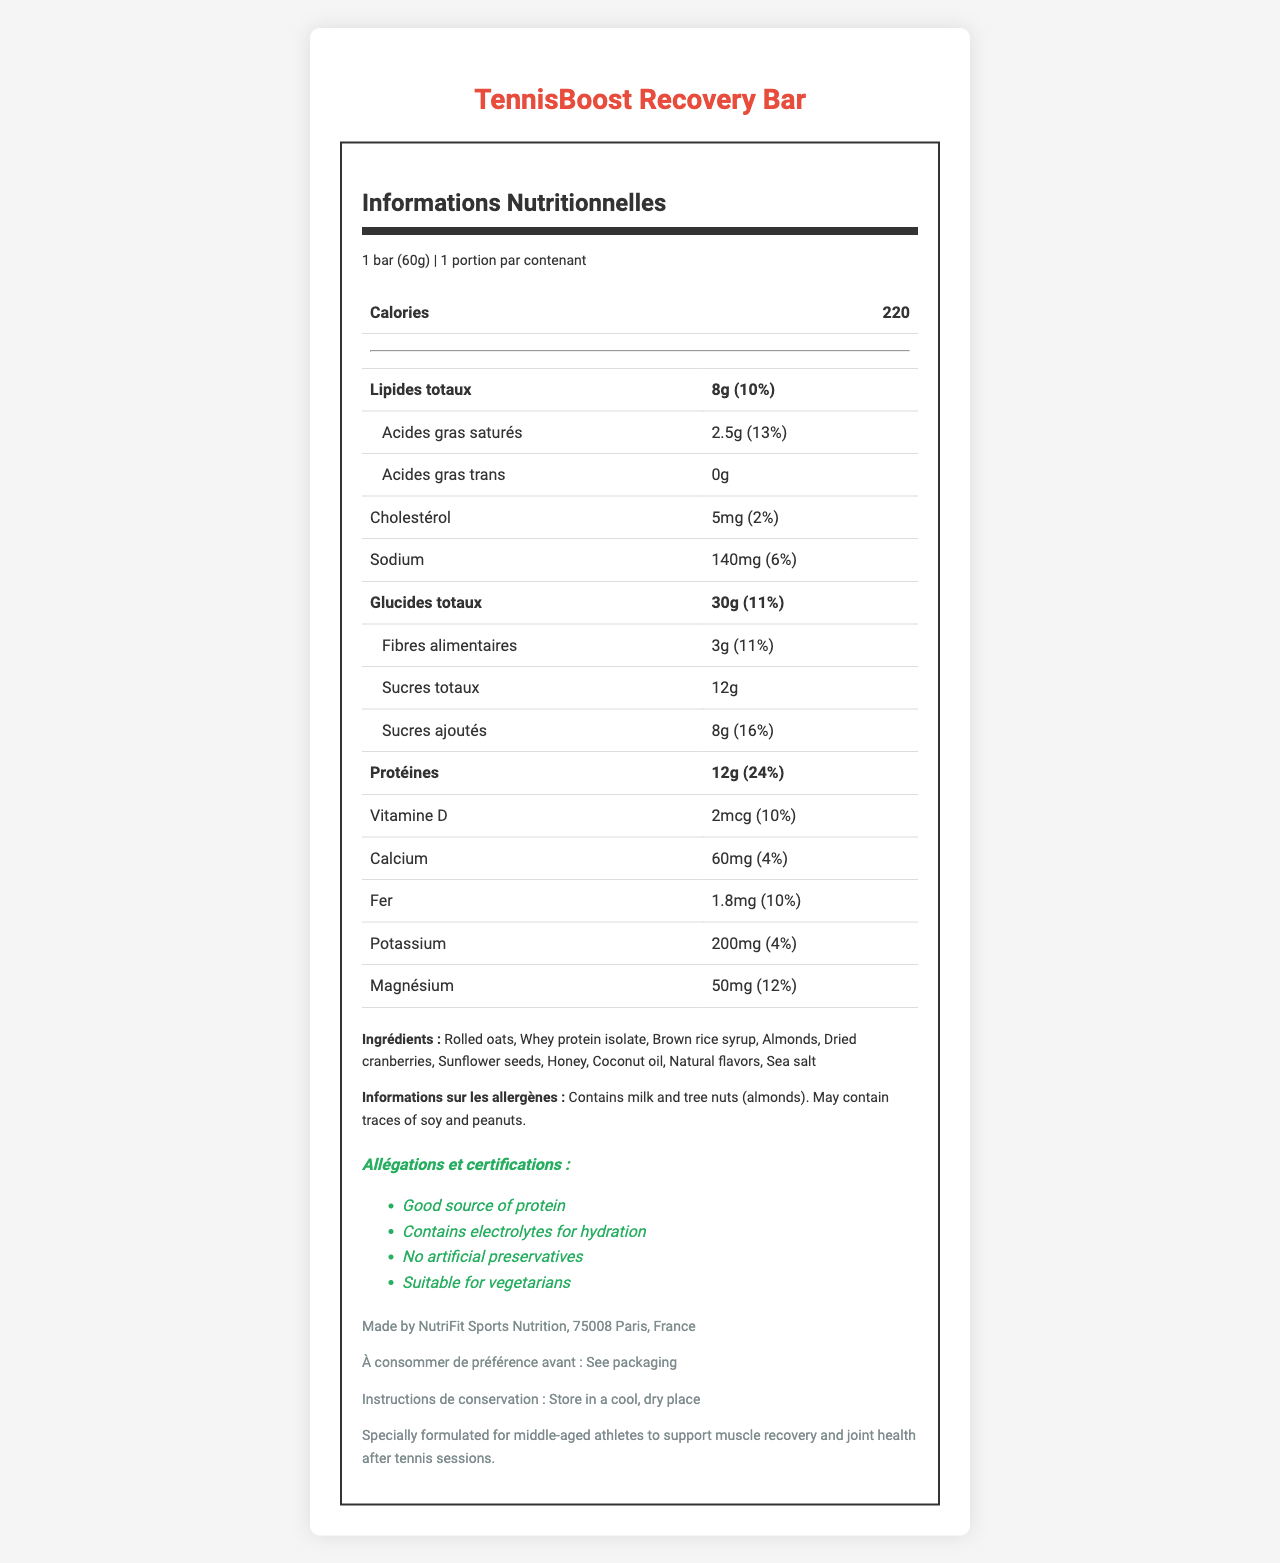what is the serving size of the TennisBoost Recovery Bar? The document specifies the serving size as "1 bar (60g)" clearly under the nutrition information.
Answer: 1 bar (60g) How many calories are there per serving of the TennisBoost Recovery Bar? The document mentions that there are 220 calories per serving, indicated in the nutrition facts.
Answer: 220 calories What is the amount of protein in one serving? The nutrition label states that one serving contains 12g of protein.
Answer: 12g What allergens are present in the TennisBoost Recovery Bar? The allergen information section indicates that the bar contains milk and tree nuts (almonds).
Answer: Milk and tree nuts (almonds) What percentage of the daily value of Vitamin D does one bar provide? According to the nutrition facts, one bar provides 10% of the daily value of Vitamin D.
Answer: 10% How much dietary fiber does the bar contain per serving? The document states that there are 3g of dietary fiber per serving.
Answer: 3g Which of the following ingredients is not listed for the TennisBoost Recovery Bar? A. Whey protein isolate B. Honey C. Dark chocolate D. Sunflower seeds The listed ingredients in the document are rolled oats, whey protein isolate, brown rice syrup, almonds, dried cranberries, sunflower seeds, honey, coconut oil, natural flavors, and sea salt, which does not include dark chocolate.
Answer: C. Dark chocolate Which of the following is a claim or certification made about the TennisBoost Recovery Bar? A. Gluten-free B. Good source of protein C. Contains artificial preservatives Among the claims and certifications, "Good source of protein" is mentioned, whereas the bar actually claims "No artificial preservatives".
Answer: B. Good source of protein Is this recovery bar suitable for vegetarians? The claims and certifications section states that the product is suitable for vegetarians.
Answer: Yes How should the TennisBoost Recovery Bar be stored? The storage instructions in the document specify storing the bar in a cool, dry place.
Answer: In a cool, dry place Does the Nutrition Facts Label mention anything about gluten? The Nutrition Facts Label does not provide any information concerning gluten.
Answer: No Summarize the document's main idea. The document provides a comprehensive overview of the TennisBoost Recovery Bar, including nutritional values like calories, fats, protein, vitamins, and minerals, as well as details on ingredients, potential allergens, and various claims such as it being a good source of protein, containing electrolytes for hydration, and being suitable for vegetarians. Further, it provides guidelines on storage and manufacturer information.
Answer: The document details the nutrition facts, ingredients, allergen information, claims and certifications, manufacturer info, best before date, storage instructions, and additional info for the TennisBoost Recovery Bar designed for middle-aged athletes. What is the percentage daily value of magnesium in one serving? The nutrition facts section lists the percentage daily value for magnesium as 12%.
Answer: 12% Who is the manufacturer of the TennisBoost Recovery Bar? The document provides the manufacturer information indicating that it is made by NutriFit Sports Nutrition, located in Paris, France.
Answer: NutriFit Sports Nutrition, 75008 Paris, France Does the bar contain any trans fat? The nutrition facts clearly state that the bar contains 0g of trans fat.
Answer: No What is the amount of potassium per serving? The document mentions that the bar contains 200mg of potassium per serving.
Answer: 200mg 